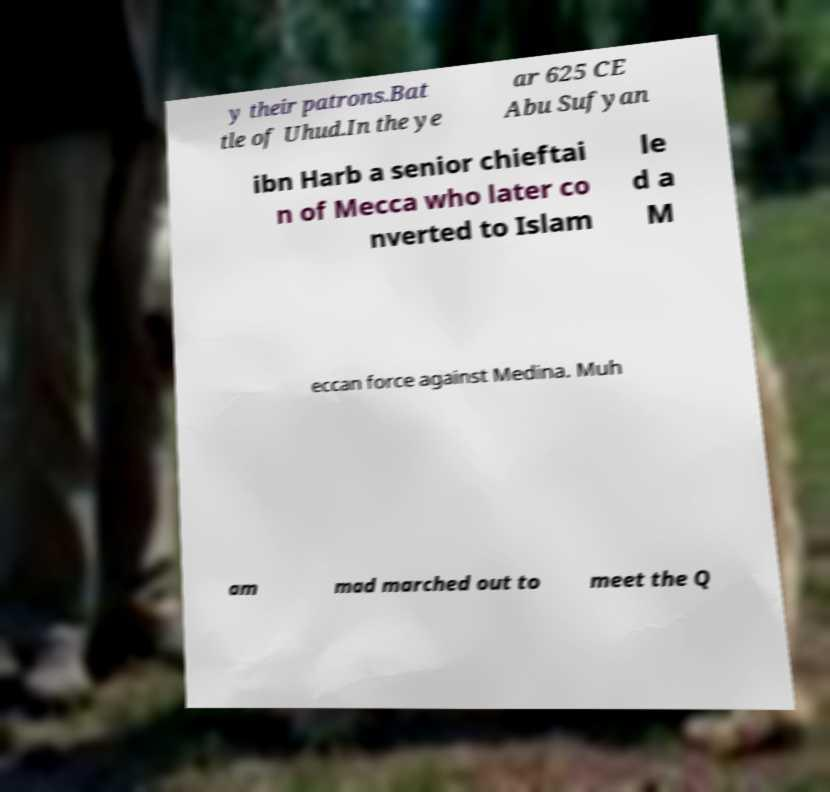Could you extract and type out the text from this image? y their patrons.Bat tle of Uhud.In the ye ar 625 CE Abu Sufyan ibn Harb a senior chieftai n of Mecca who later co nverted to Islam le d a M eccan force against Medina. Muh am mad marched out to meet the Q 